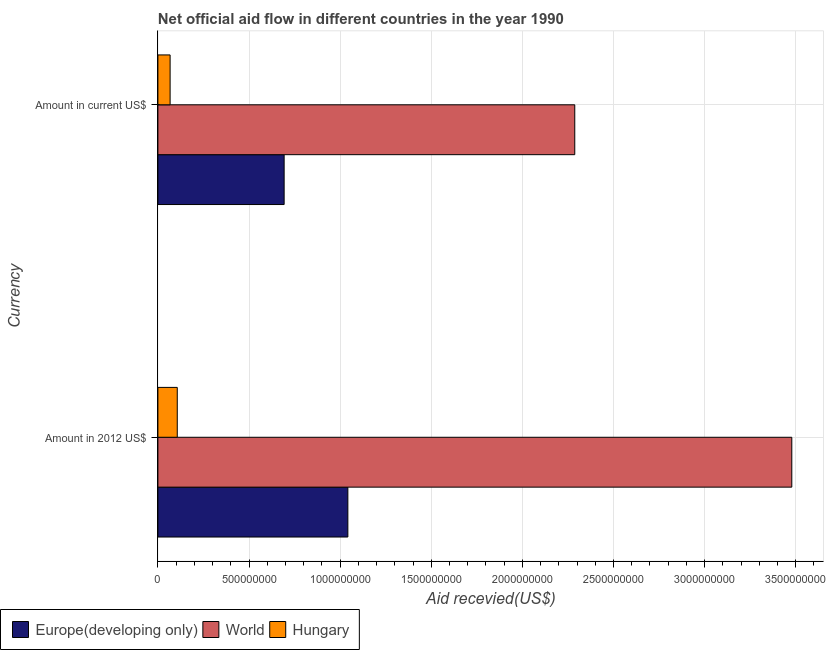How many groups of bars are there?
Your answer should be very brief. 2. Are the number of bars per tick equal to the number of legend labels?
Keep it short and to the point. Yes. How many bars are there on the 2nd tick from the bottom?
Provide a succinct answer. 3. What is the label of the 1st group of bars from the top?
Your response must be concise. Amount in current US$. What is the amount of aid received(expressed in 2012 us$) in Europe(developing only)?
Ensure brevity in your answer.  1.04e+09. Across all countries, what is the maximum amount of aid received(expressed in us$)?
Keep it short and to the point. 2.29e+09. Across all countries, what is the minimum amount of aid received(expressed in us$)?
Offer a very short reply. 6.70e+07. In which country was the amount of aid received(expressed in us$) maximum?
Give a very brief answer. World. In which country was the amount of aid received(expressed in us$) minimum?
Your answer should be compact. Hungary. What is the total amount of aid received(expressed in 2012 us$) in the graph?
Ensure brevity in your answer.  4.63e+09. What is the difference between the amount of aid received(expressed in 2012 us$) in Hungary and that in Europe(developing only)?
Provide a succinct answer. -9.36e+08. What is the difference between the amount of aid received(expressed in 2012 us$) in Europe(developing only) and the amount of aid received(expressed in us$) in World?
Provide a short and direct response. -1.25e+09. What is the average amount of aid received(expressed in 2012 us$) per country?
Ensure brevity in your answer.  1.54e+09. What is the difference between the amount of aid received(expressed in 2012 us$) and amount of aid received(expressed in us$) in World?
Your answer should be compact. 1.19e+09. In how many countries, is the amount of aid received(expressed in us$) greater than 2200000000 US$?
Keep it short and to the point. 1. What is the ratio of the amount of aid received(expressed in us$) in World to that in Europe(developing only)?
Ensure brevity in your answer.  3.3. Is the amount of aid received(expressed in us$) in Hungary less than that in Europe(developing only)?
Keep it short and to the point. Yes. What does the 1st bar from the top in Amount in current US$ represents?
Your answer should be very brief. Hungary. Are all the bars in the graph horizontal?
Your answer should be compact. Yes. How many countries are there in the graph?
Give a very brief answer. 3. Does the graph contain any zero values?
Provide a succinct answer. No. What is the title of the graph?
Provide a succinct answer. Net official aid flow in different countries in the year 1990. Does "India" appear as one of the legend labels in the graph?
Provide a short and direct response. No. What is the label or title of the X-axis?
Ensure brevity in your answer.  Aid recevied(US$). What is the label or title of the Y-axis?
Make the answer very short. Currency. What is the Aid recevied(US$) of Europe(developing only) in Amount in 2012 US$?
Your answer should be compact. 1.04e+09. What is the Aid recevied(US$) of World in Amount in 2012 US$?
Make the answer very short. 3.48e+09. What is the Aid recevied(US$) of Hungary in Amount in 2012 US$?
Keep it short and to the point. 1.06e+08. What is the Aid recevied(US$) of Europe(developing only) in Amount in current US$?
Your answer should be compact. 6.93e+08. What is the Aid recevied(US$) in World in Amount in current US$?
Make the answer very short. 2.29e+09. What is the Aid recevied(US$) in Hungary in Amount in current US$?
Ensure brevity in your answer.  6.70e+07. Across all Currency, what is the maximum Aid recevied(US$) in Europe(developing only)?
Ensure brevity in your answer.  1.04e+09. Across all Currency, what is the maximum Aid recevied(US$) in World?
Offer a terse response. 3.48e+09. Across all Currency, what is the maximum Aid recevied(US$) of Hungary?
Make the answer very short. 1.06e+08. Across all Currency, what is the minimum Aid recevied(US$) of Europe(developing only)?
Offer a terse response. 6.93e+08. Across all Currency, what is the minimum Aid recevied(US$) in World?
Give a very brief answer. 2.29e+09. Across all Currency, what is the minimum Aid recevied(US$) in Hungary?
Keep it short and to the point. 6.70e+07. What is the total Aid recevied(US$) of Europe(developing only) in the graph?
Your answer should be compact. 1.74e+09. What is the total Aid recevied(US$) in World in the graph?
Keep it short and to the point. 5.77e+09. What is the total Aid recevied(US$) in Hungary in the graph?
Provide a succinct answer. 1.73e+08. What is the difference between the Aid recevied(US$) of Europe(developing only) in Amount in 2012 US$ and that in Amount in current US$?
Your answer should be very brief. 3.50e+08. What is the difference between the Aid recevied(US$) of World in Amount in 2012 US$ and that in Amount in current US$?
Your response must be concise. 1.19e+09. What is the difference between the Aid recevied(US$) in Hungary in Amount in 2012 US$ and that in Amount in current US$?
Keep it short and to the point. 3.93e+07. What is the difference between the Aid recevied(US$) of Europe(developing only) in Amount in 2012 US$ and the Aid recevied(US$) of World in Amount in current US$?
Provide a short and direct response. -1.25e+09. What is the difference between the Aid recevied(US$) of Europe(developing only) in Amount in 2012 US$ and the Aid recevied(US$) of Hungary in Amount in current US$?
Ensure brevity in your answer.  9.75e+08. What is the difference between the Aid recevied(US$) in World in Amount in 2012 US$ and the Aid recevied(US$) in Hungary in Amount in current US$?
Ensure brevity in your answer.  3.41e+09. What is the average Aid recevied(US$) of Europe(developing only) per Currency?
Provide a short and direct response. 8.68e+08. What is the average Aid recevied(US$) of World per Currency?
Your answer should be compact. 2.88e+09. What is the average Aid recevied(US$) of Hungary per Currency?
Provide a succinct answer. 8.66e+07. What is the difference between the Aid recevied(US$) of Europe(developing only) and Aid recevied(US$) of World in Amount in 2012 US$?
Give a very brief answer. -2.44e+09. What is the difference between the Aid recevied(US$) of Europe(developing only) and Aid recevied(US$) of Hungary in Amount in 2012 US$?
Offer a very short reply. 9.36e+08. What is the difference between the Aid recevied(US$) of World and Aid recevied(US$) of Hungary in Amount in 2012 US$?
Offer a very short reply. 3.37e+09. What is the difference between the Aid recevied(US$) in Europe(developing only) and Aid recevied(US$) in World in Amount in current US$?
Your response must be concise. -1.59e+09. What is the difference between the Aid recevied(US$) in Europe(developing only) and Aid recevied(US$) in Hungary in Amount in current US$?
Give a very brief answer. 6.26e+08. What is the difference between the Aid recevied(US$) of World and Aid recevied(US$) of Hungary in Amount in current US$?
Your answer should be compact. 2.22e+09. What is the ratio of the Aid recevied(US$) in Europe(developing only) in Amount in 2012 US$ to that in Amount in current US$?
Provide a short and direct response. 1.5. What is the ratio of the Aid recevied(US$) in World in Amount in 2012 US$ to that in Amount in current US$?
Offer a terse response. 1.52. What is the ratio of the Aid recevied(US$) in Hungary in Amount in 2012 US$ to that in Amount in current US$?
Your response must be concise. 1.59. What is the difference between the highest and the second highest Aid recevied(US$) of Europe(developing only)?
Your answer should be compact. 3.50e+08. What is the difference between the highest and the second highest Aid recevied(US$) in World?
Your answer should be compact. 1.19e+09. What is the difference between the highest and the second highest Aid recevied(US$) of Hungary?
Make the answer very short. 3.93e+07. What is the difference between the highest and the lowest Aid recevied(US$) in Europe(developing only)?
Keep it short and to the point. 3.50e+08. What is the difference between the highest and the lowest Aid recevied(US$) in World?
Keep it short and to the point. 1.19e+09. What is the difference between the highest and the lowest Aid recevied(US$) in Hungary?
Give a very brief answer. 3.93e+07. 